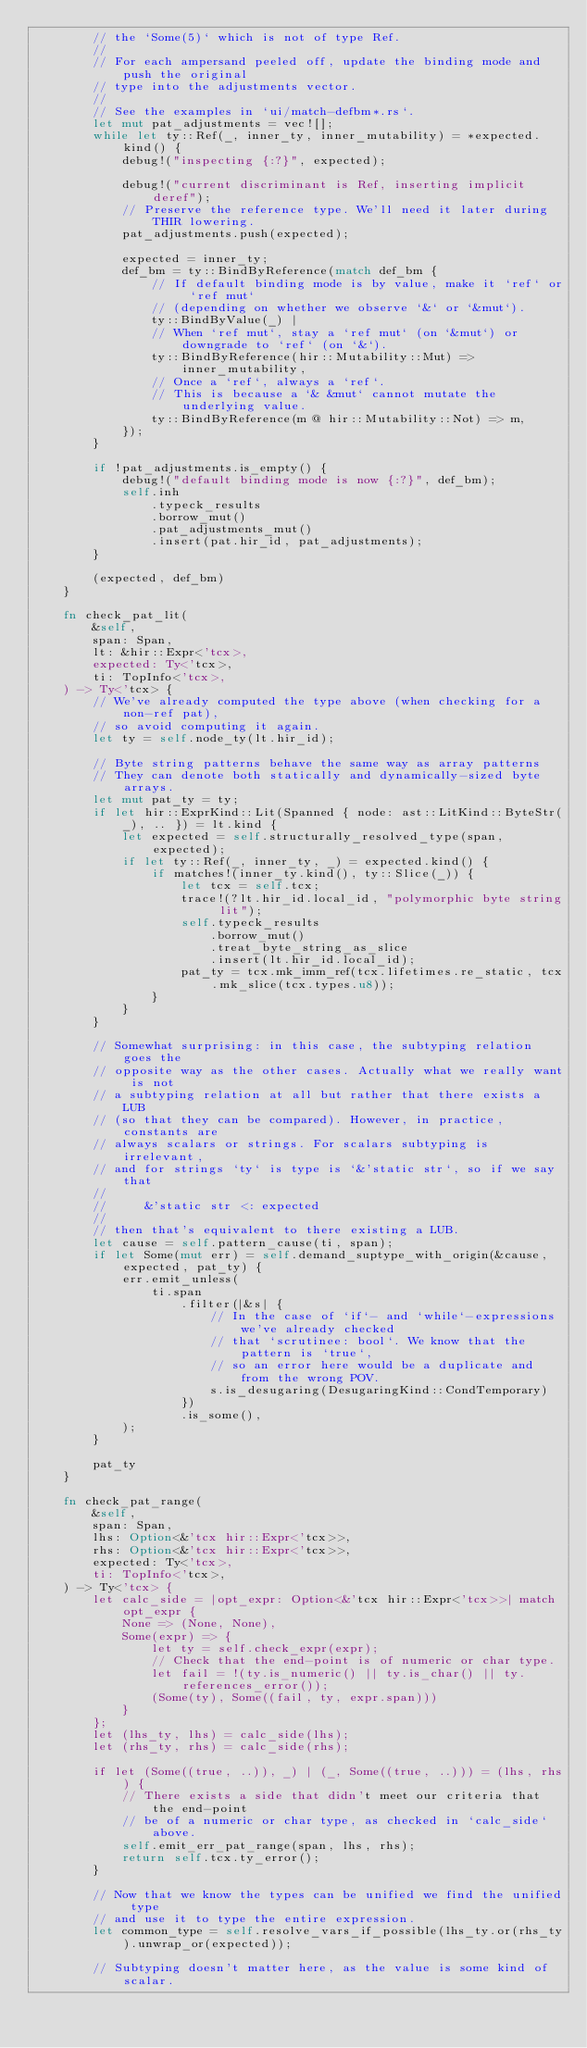<code> <loc_0><loc_0><loc_500><loc_500><_Rust_>        // the `Some(5)` which is not of type Ref.
        //
        // For each ampersand peeled off, update the binding mode and push the original
        // type into the adjustments vector.
        //
        // See the examples in `ui/match-defbm*.rs`.
        let mut pat_adjustments = vec![];
        while let ty::Ref(_, inner_ty, inner_mutability) = *expected.kind() {
            debug!("inspecting {:?}", expected);

            debug!("current discriminant is Ref, inserting implicit deref");
            // Preserve the reference type. We'll need it later during THIR lowering.
            pat_adjustments.push(expected);

            expected = inner_ty;
            def_bm = ty::BindByReference(match def_bm {
                // If default binding mode is by value, make it `ref` or `ref mut`
                // (depending on whether we observe `&` or `&mut`).
                ty::BindByValue(_) |
                // When `ref mut`, stay a `ref mut` (on `&mut`) or downgrade to `ref` (on `&`).
                ty::BindByReference(hir::Mutability::Mut) => inner_mutability,
                // Once a `ref`, always a `ref`.
                // This is because a `& &mut` cannot mutate the underlying value.
                ty::BindByReference(m @ hir::Mutability::Not) => m,
            });
        }

        if !pat_adjustments.is_empty() {
            debug!("default binding mode is now {:?}", def_bm);
            self.inh
                .typeck_results
                .borrow_mut()
                .pat_adjustments_mut()
                .insert(pat.hir_id, pat_adjustments);
        }

        (expected, def_bm)
    }

    fn check_pat_lit(
        &self,
        span: Span,
        lt: &hir::Expr<'tcx>,
        expected: Ty<'tcx>,
        ti: TopInfo<'tcx>,
    ) -> Ty<'tcx> {
        // We've already computed the type above (when checking for a non-ref pat),
        // so avoid computing it again.
        let ty = self.node_ty(lt.hir_id);

        // Byte string patterns behave the same way as array patterns
        // They can denote both statically and dynamically-sized byte arrays.
        let mut pat_ty = ty;
        if let hir::ExprKind::Lit(Spanned { node: ast::LitKind::ByteStr(_), .. }) = lt.kind {
            let expected = self.structurally_resolved_type(span, expected);
            if let ty::Ref(_, inner_ty, _) = expected.kind() {
                if matches!(inner_ty.kind(), ty::Slice(_)) {
                    let tcx = self.tcx;
                    trace!(?lt.hir_id.local_id, "polymorphic byte string lit");
                    self.typeck_results
                        .borrow_mut()
                        .treat_byte_string_as_slice
                        .insert(lt.hir_id.local_id);
                    pat_ty = tcx.mk_imm_ref(tcx.lifetimes.re_static, tcx.mk_slice(tcx.types.u8));
                }
            }
        }

        // Somewhat surprising: in this case, the subtyping relation goes the
        // opposite way as the other cases. Actually what we really want is not
        // a subtyping relation at all but rather that there exists a LUB
        // (so that they can be compared). However, in practice, constants are
        // always scalars or strings. For scalars subtyping is irrelevant,
        // and for strings `ty` is type is `&'static str`, so if we say that
        //
        //     &'static str <: expected
        //
        // then that's equivalent to there existing a LUB.
        let cause = self.pattern_cause(ti, span);
        if let Some(mut err) = self.demand_suptype_with_origin(&cause, expected, pat_ty) {
            err.emit_unless(
                ti.span
                    .filter(|&s| {
                        // In the case of `if`- and `while`-expressions we've already checked
                        // that `scrutinee: bool`. We know that the pattern is `true`,
                        // so an error here would be a duplicate and from the wrong POV.
                        s.is_desugaring(DesugaringKind::CondTemporary)
                    })
                    .is_some(),
            );
        }

        pat_ty
    }

    fn check_pat_range(
        &self,
        span: Span,
        lhs: Option<&'tcx hir::Expr<'tcx>>,
        rhs: Option<&'tcx hir::Expr<'tcx>>,
        expected: Ty<'tcx>,
        ti: TopInfo<'tcx>,
    ) -> Ty<'tcx> {
        let calc_side = |opt_expr: Option<&'tcx hir::Expr<'tcx>>| match opt_expr {
            None => (None, None),
            Some(expr) => {
                let ty = self.check_expr(expr);
                // Check that the end-point is of numeric or char type.
                let fail = !(ty.is_numeric() || ty.is_char() || ty.references_error());
                (Some(ty), Some((fail, ty, expr.span)))
            }
        };
        let (lhs_ty, lhs) = calc_side(lhs);
        let (rhs_ty, rhs) = calc_side(rhs);

        if let (Some((true, ..)), _) | (_, Some((true, ..))) = (lhs, rhs) {
            // There exists a side that didn't meet our criteria that the end-point
            // be of a numeric or char type, as checked in `calc_side` above.
            self.emit_err_pat_range(span, lhs, rhs);
            return self.tcx.ty_error();
        }

        // Now that we know the types can be unified we find the unified type
        // and use it to type the entire expression.
        let common_type = self.resolve_vars_if_possible(lhs_ty.or(rhs_ty).unwrap_or(expected));

        // Subtyping doesn't matter here, as the value is some kind of scalar.</code> 